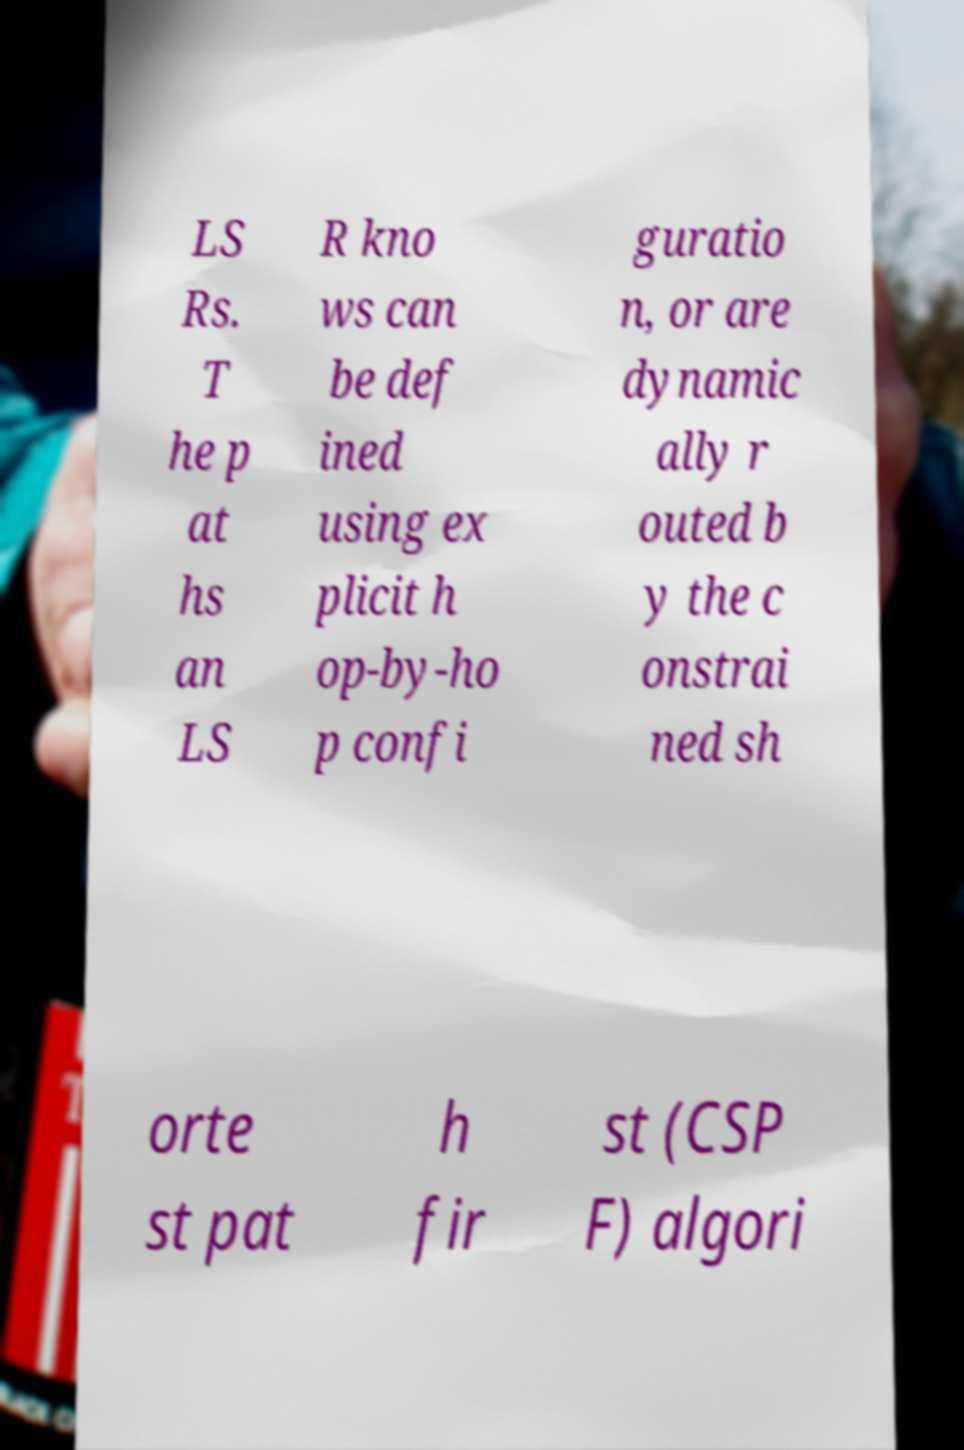For documentation purposes, I need the text within this image transcribed. Could you provide that? LS Rs. T he p at hs an LS R kno ws can be def ined using ex plicit h op-by-ho p confi guratio n, or are dynamic ally r outed b y the c onstrai ned sh orte st pat h fir st (CSP F) algori 